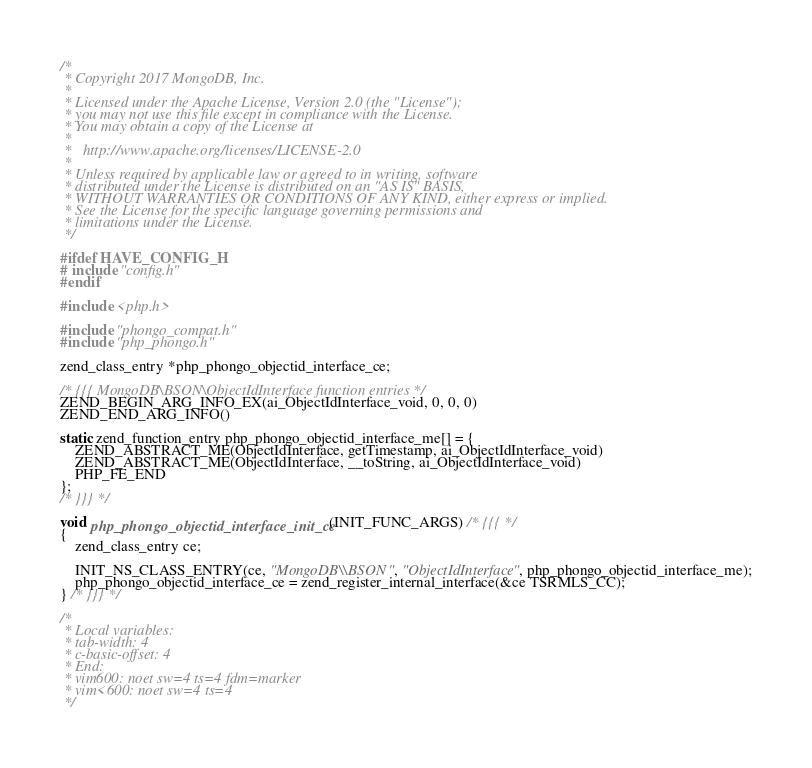Convert code to text. <code><loc_0><loc_0><loc_500><loc_500><_C_>/*
 * Copyright 2017 MongoDB, Inc.
 *
 * Licensed under the Apache License, Version 2.0 (the "License");
 * you may not use this file except in compliance with the License.
 * You may obtain a copy of the License at
 *
 *   http://www.apache.org/licenses/LICENSE-2.0
 *
 * Unless required by applicable law or agreed to in writing, software
 * distributed under the License is distributed on an "AS IS" BASIS,
 * WITHOUT WARRANTIES OR CONDITIONS OF ANY KIND, either express or implied.
 * See the License for the specific language governing permissions and
 * limitations under the License.
 */

#ifdef HAVE_CONFIG_H
# include "config.h"
#endif

#include <php.h> 

#include "phongo_compat.h"
#include "php_phongo.h"

zend_class_entry *php_phongo_objectid_interface_ce;

/* {{{ MongoDB\BSON\ObjectIdInterface function entries */
ZEND_BEGIN_ARG_INFO_EX(ai_ObjectIdInterface_void, 0, 0, 0)
ZEND_END_ARG_INFO()

static zend_function_entry php_phongo_objectid_interface_me[] = {
	ZEND_ABSTRACT_ME(ObjectIdInterface, getTimestamp, ai_ObjectIdInterface_void)
	ZEND_ABSTRACT_ME(ObjectIdInterface, __toString, ai_ObjectIdInterface_void)
	PHP_FE_END
};
/* }}} */

void php_phongo_objectid_interface_init_ce(INIT_FUNC_ARGS) /* {{{ */
{
	zend_class_entry ce;

	INIT_NS_CLASS_ENTRY(ce, "MongoDB\\BSON", "ObjectIdInterface", php_phongo_objectid_interface_me);
	php_phongo_objectid_interface_ce = zend_register_internal_interface(&ce TSRMLS_CC);
} /* }}} */

/*
 * Local variables:
 * tab-width: 4
 * c-basic-offset: 4
 * End:
 * vim600: noet sw=4 ts=4 fdm=marker
 * vim<600: noet sw=4 ts=4
 */
</code> 